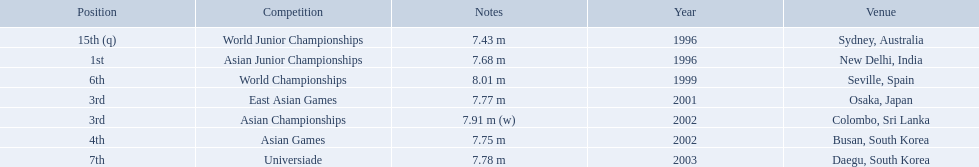What rankings has this competitor placed through the competitions? 15th (q), 1st, 6th, 3rd, 3rd, 4th, 7th. In which competition did the competitor place 1st? Asian Junior Championships. Which competition did huang le achieve 3rd place? East Asian Games. Which competition did he achieve 4th place? Asian Games. When did he achieve 1st place? Asian Junior Championships. 